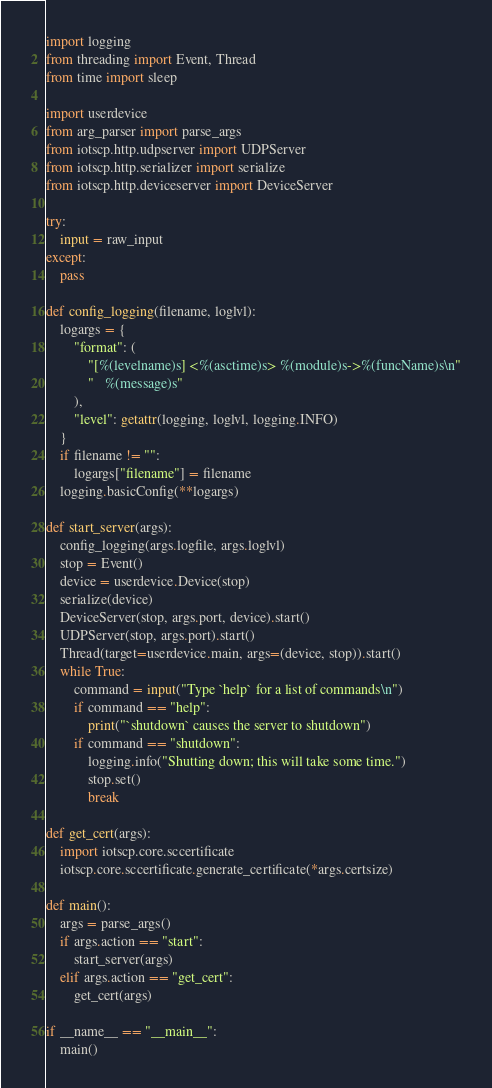<code> <loc_0><loc_0><loc_500><loc_500><_Python_>import logging
from threading import Event, Thread
from time import sleep

import userdevice
from arg_parser import parse_args
from iotscp.http.udpserver import UDPServer
from iotscp.http.serializer import serialize
from iotscp.http.deviceserver import DeviceServer

try:
    input = raw_input
except:
    pass

def config_logging(filename, loglvl):
    logargs = {
        "format": (
            "[%(levelname)s] <%(asctime)s> %(module)s->%(funcName)s\n"
            "   %(message)s"
        ),
        "level": getattr(logging, loglvl, logging.INFO)
    }
    if filename != "":
        logargs["filename"] = filename
    logging.basicConfig(**logargs)

def start_server(args):
    config_logging(args.logfile, args.loglvl)
    stop = Event()
    device = userdevice.Device(stop)
    serialize(device)
    DeviceServer(stop, args.port, device).start()
    UDPServer(stop, args.port).start()
    Thread(target=userdevice.main, args=(device, stop)).start()
    while True:
        command = input("Type `help` for a list of commands\n")
        if command == "help":
            print("`shutdown` causes the server to shutdown")
        if command == "shutdown":
            logging.info("Shutting down; this will take some time.")
            stop.set()
            break

def get_cert(args):
    import iotscp.core.sccertificate
    iotscp.core.sccertificate.generate_certificate(*args.certsize)

def main():
    args = parse_args()
    if args.action == "start":
        start_server(args)
    elif args.action == "get_cert":
        get_cert(args)

if __name__ == "__main__":
    main()
</code> 